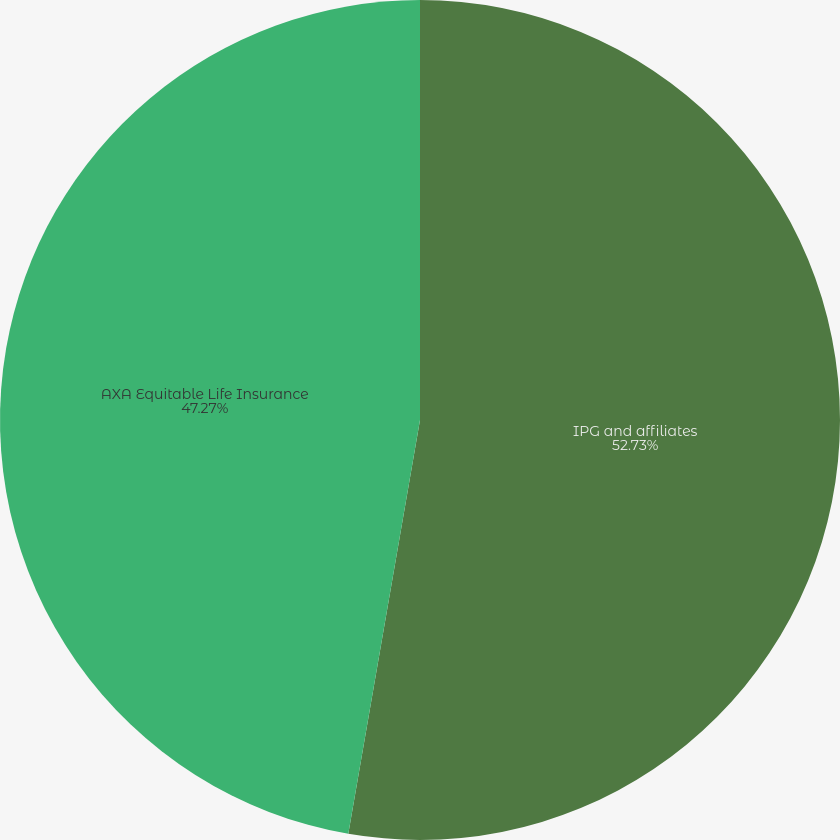Convert chart to OTSL. <chart><loc_0><loc_0><loc_500><loc_500><pie_chart><fcel>IPG and affiliates<fcel>AXA Equitable Life Insurance<nl><fcel>52.73%<fcel>47.27%<nl></chart> 